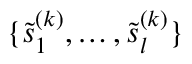Convert formula to latex. <formula><loc_0><loc_0><loc_500><loc_500>\{ \tilde { s } _ { 1 } ^ { ( k ) } , \dots , \tilde { s } _ { l } ^ { ( k ) } \}</formula> 